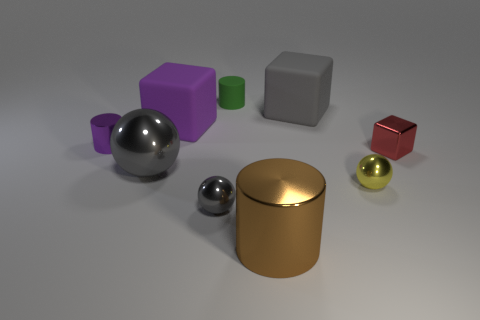Add 1 large purple shiny cylinders. How many objects exist? 10 Subtract all cubes. How many objects are left? 6 Add 3 rubber blocks. How many rubber blocks are left? 5 Add 7 big red metal cubes. How many big red metal cubes exist? 7 Subtract 0 blue balls. How many objects are left? 9 Subtract all big purple matte cubes. Subtract all rubber blocks. How many objects are left? 6 